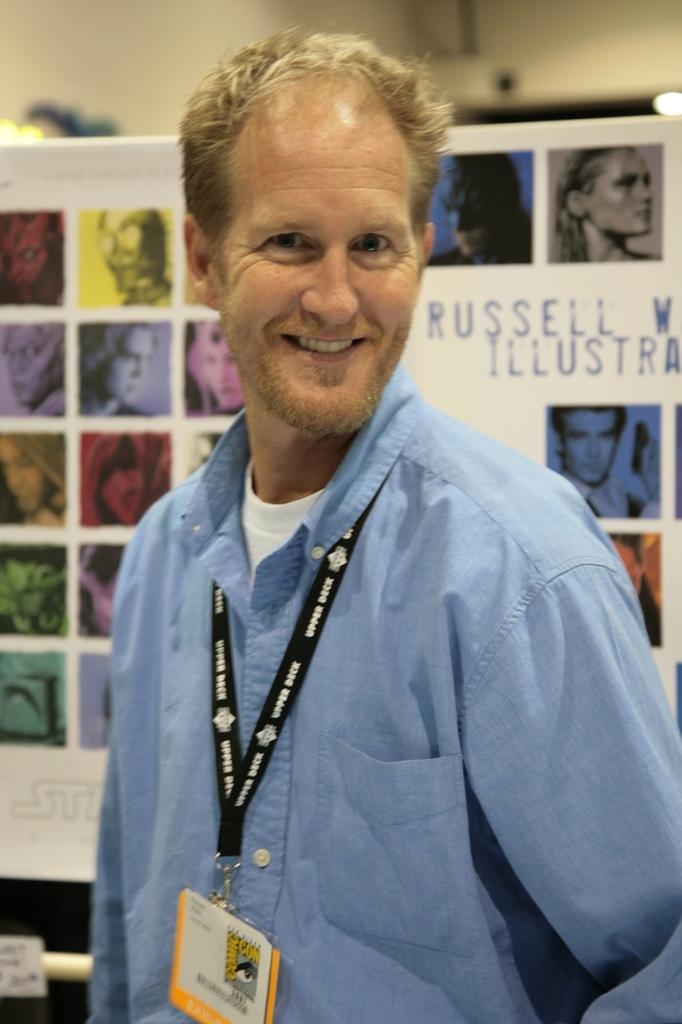In one or two sentences, can you explain what this image depicts? In the picture I can see a man is standing and smiling. The man is wearing an ID card and a blue color shirt. In the background I can see a board which has photos of people and something written on it. 